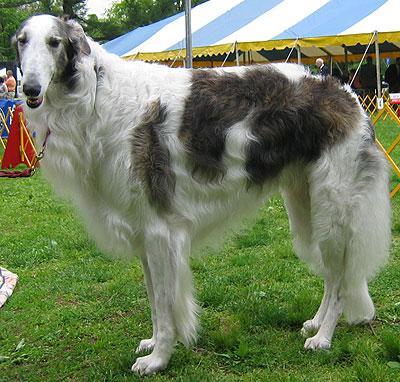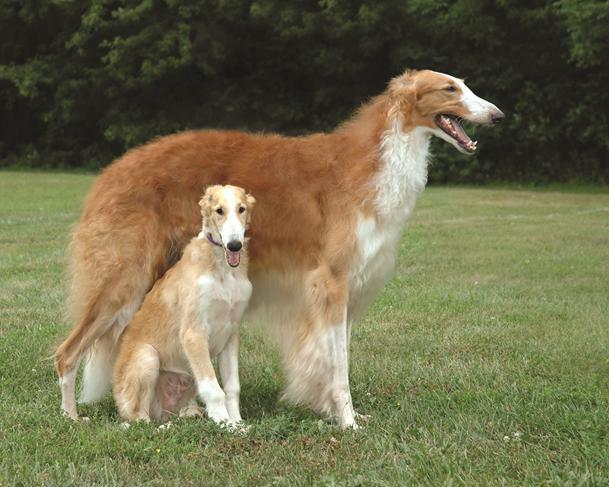The first image is the image on the left, the second image is the image on the right. Evaluate the accuracy of this statement regarding the images: "There are more dogs outside in the image on the right.". Is it true? Answer yes or no. Yes. The first image is the image on the left, the second image is the image on the right. Analyze the images presented: Is the assertion "The lefthand image contains one gray-and-white hound standing with its body turned leftward and face to the camera." valid? Answer yes or no. Yes. 